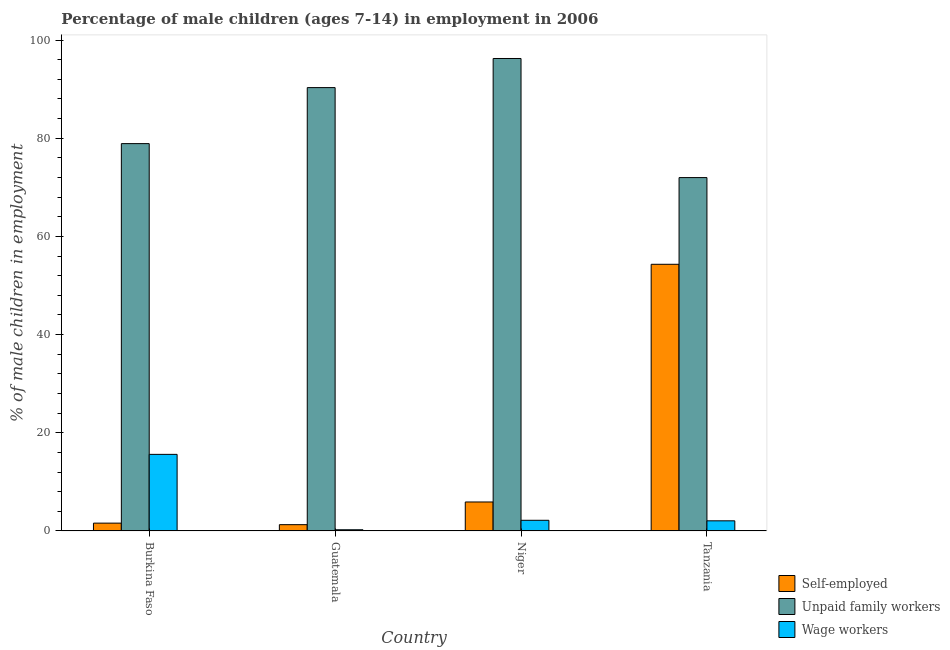How many bars are there on the 3rd tick from the left?
Give a very brief answer. 3. What is the label of the 1st group of bars from the left?
Provide a short and direct response. Burkina Faso. In how many cases, is the number of bars for a given country not equal to the number of legend labels?
Offer a very short reply. 0. What is the percentage of children employed as unpaid family workers in Guatemala?
Your answer should be compact. 90.31. Across all countries, what is the maximum percentage of children employed as unpaid family workers?
Provide a short and direct response. 96.24. Across all countries, what is the minimum percentage of children employed as unpaid family workers?
Your response must be concise. 71.98. In which country was the percentage of children employed as wage workers maximum?
Ensure brevity in your answer.  Burkina Faso. In which country was the percentage of children employed as wage workers minimum?
Provide a short and direct response. Guatemala. What is the total percentage of self employed children in the graph?
Your response must be concise. 63.09. What is the difference between the percentage of children employed as wage workers in Guatemala and that in Niger?
Your response must be concise. -1.93. What is the difference between the percentage of children employed as unpaid family workers in Guatemala and the percentage of self employed children in Tanzania?
Offer a very short reply. 35.99. What is the average percentage of self employed children per country?
Provide a short and direct response. 15.77. What is the difference between the percentage of self employed children and percentage of children employed as unpaid family workers in Burkina Faso?
Provide a succinct answer. -77.31. What is the ratio of the percentage of self employed children in Guatemala to that in Tanzania?
Your response must be concise. 0.02. What is the difference between the highest and the second highest percentage of children employed as wage workers?
Offer a very short reply. 13.43. What is the difference between the highest and the lowest percentage of self employed children?
Ensure brevity in your answer.  53.04. In how many countries, is the percentage of children employed as wage workers greater than the average percentage of children employed as wage workers taken over all countries?
Your response must be concise. 1. Is the sum of the percentage of children employed as wage workers in Guatemala and Tanzania greater than the maximum percentage of children employed as unpaid family workers across all countries?
Offer a terse response. No. What does the 3rd bar from the left in Burkina Faso represents?
Your answer should be compact. Wage workers. What does the 1st bar from the right in Guatemala represents?
Offer a very short reply. Wage workers. How many bars are there?
Give a very brief answer. 12. Are all the bars in the graph horizontal?
Your answer should be compact. No. What is the difference between two consecutive major ticks on the Y-axis?
Make the answer very short. 20. Does the graph contain grids?
Offer a terse response. No. What is the title of the graph?
Offer a very short reply. Percentage of male children (ages 7-14) in employment in 2006. Does "Primary" appear as one of the legend labels in the graph?
Keep it short and to the point. No. What is the label or title of the Y-axis?
Give a very brief answer. % of male children in employment. What is the % of male children in employment in Self-employed in Burkina Faso?
Your response must be concise. 1.59. What is the % of male children in employment in Unpaid family workers in Burkina Faso?
Your answer should be very brief. 78.9. What is the % of male children in employment in Wage workers in Burkina Faso?
Give a very brief answer. 15.6. What is the % of male children in employment of Self-employed in Guatemala?
Provide a succinct answer. 1.28. What is the % of male children in employment in Unpaid family workers in Guatemala?
Offer a very short reply. 90.31. What is the % of male children in employment of Wage workers in Guatemala?
Provide a succinct answer. 0.24. What is the % of male children in employment in Unpaid family workers in Niger?
Provide a succinct answer. 96.24. What is the % of male children in employment of Wage workers in Niger?
Provide a short and direct response. 2.17. What is the % of male children in employment in Self-employed in Tanzania?
Make the answer very short. 54.32. What is the % of male children in employment of Unpaid family workers in Tanzania?
Offer a very short reply. 71.98. What is the % of male children in employment in Wage workers in Tanzania?
Provide a short and direct response. 2.06. Across all countries, what is the maximum % of male children in employment of Self-employed?
Give a very brief answer. 54.32. Across all countries, what is the maximum % of male children in employment in Unpaid family workers?
Offer a terse response. 96.24. Across all countries, what is the minimum % of male children in employment of Self-employed?
Ensure brevity in your answer.  1.28. Across all countries, what is the minimum % of male children in employment in Unpaid family workers?
Keep it short and to the point. 71.98. Across all countries, what is the minimum % of male children in employment of Wage workers?
Your answer should be very brief. 0.24. What is the total % of male children in employment in Self-employed in the graph?
Your answer should be compact. 63.09. What is the total % of male children in employment of Unpaid family workers in the graph?
Provide a succinct answer. 337.43. What is the total % of male children in employment in Wage workers in the graph?
Ensure brevity in your answer.  20.07. What is the difference between the % of male children in employment in Self-employed in Burkina Faso and that in Guatemala?
Provide a succinct answer. 0.31. What is the difference between the % of male children in employment in Unpaid family workers in Burkina Faso and that in Guatemala?
Give a very brief answer. -11.41. What is the difference between the % of male children in employment of Wage workers in Burkina Faso and that in Guatemala?
Your answer should be compact. 15.36. What is the difference between the % of male children in employment in Self-employed in Burkina Faso and that in Niger?
Your answer should be compact. -4.31. What is the difference between the % of male children in employment in Unpaid family workers in Burkina Faso and that in Niger?
Provide a short and direct response. -17.34. What is the difference between the % of male children in employment in Wage workers in Burkina Faso and that in Niger?
Your answer should be very brief. 13.43. What is the difference between the % of male children in employment of Self-employed in Burkina Faso and that in Tanzania?
Offer a very short reply. -52.73. What is the difference between the % of male children in employment in Unpaid family workers in Burkina Faso and that in Tanzania?
Your answer should be very brief. 6.92. What is the difference between the % of male children in employment in Wage workers in Burkina Faso and that in Tanzania?
Your answer should be compact. 13.54. What is the difference between the % of male children in employment in Self-employed in Guatemala and that in Niger?
Offer a terse response. -4.62. What is the difference between the % of male children in employment of Unpaid family workers in Guatemala and that in Niger?
Keep it short and to the point. -5.93. What is the difference between the % of male children in employment in Wage workers in Guatemala and that in Niger?
Provide a succinct answer. -1.93. What is the difference between the % of male children in employment in Self-employed in Guatemala and that in Tanzania?
Offer a very short reply. -53.04. What is the difference between the % of male children in employment in Unpaid family workers in Guatemala and that in Tanzania?
Provide a succinct answer. 18.33. What is the difference between the % of male children in employment of Wage workers in Guatemala and that in Tanzania?
Keep it short and to the point. -1.82. What is the difference between the % of male children in employment in Self-employed in Niger and that in Tanzania?
Ensure brevity in your answer.  -48.42. What is the difference between the % of male children in employment in Unpaid family workers in Niger and that in Tanzania?
Ensure brevity in your answer.  24.26. What is the difference between the % of male children in employment of Wage workers in Niger and that in Tanzania?
Provide a short and direct response. 0.11. What is the difference between the % of male children in employment of Self-employed in Burkina Faso and the % of male children in employment of Unpaid family workers in Guatemala?
Offer a terse response. -88.72. What is the difference between the % of male children in employment in Self-employed in Burkina Faso and the % of male children in employment in Wage workers in Guatemala?
Offer a terse response. 1.35. What is the difference between the % of male children in employment of Unpaid family workers in Burkina Faso and the % of male children in employment of Wage workers in Guatemala?
Your response must be concise. 78.66. What is the difference between the % of male children in employment of Self-employed in Burkina Faso and the % of male children in employment of Unpaid family workers in Niger?
Offer a terse response. -94.65. What is the difference between the % of male children in employment in Self-employed in Burkina Faso and the % of male children in employment in Wage workers in Niger?
Offer a very short reply. -0.58. What is the difference between the % of male children in employment in Unpaid family workers in Burkina Faso and the % of male children in employment in Wage workers in Niger?
Provide a short and direct response. 76.73. What is the difference between the % of male children in employment of Self-employed in Burkina Faso and the % of male children in employment of Unpaid family workers in Tanzania?
Offer a terse response. -70.39. What is the difference between the % of male children in employment in Self-employed in Burkina Faso and the % of male children in employment in Wage workers in Tanzania?
Ensure brevity in your answer.  -0.47. What is the difference between the % of male children in employment of Unpaid family workers in Burkina Faso and the % of male children in employment of Wage workers in Tanzania?
Make the answer very short. 76.84. What is the difference between the % of male children in employment of Self-employed in Guatemala and the % of male children in employment of Unpaid family workers in Niger?
Give a very brief answer. -94.96. What is the difference between the % of male children in employment in Self-employed in Guatemala and the % of male children in employment in Wage workers in Niger?
Make the answer very short. -0.89. What is the difference between the % of male children in employment in Unpaid family workers in Guatemala and the % of male children in employment in Wage workers in Niger?
Give a very brief answer. 88.14. What is the difference between the % of male children in employment of Self-employed in Guatemala and the % of male children in employment of Unpaid family workers in Tanzania?
Provide a succinct answer. -70.7. What is the difference between the % of male children in employment of Self-employed in Guatemala and the % of male children in employment of Wage workers in Tanzania?
Give a very brief answer. -0.78. What is the difference between the % of male children in employment in Unpaid family workers in Guatemala and the % of male children in employment in Wage workers in Tanzania?
Your answer should be very brief. 88.25. What is the difference between the % of male children in employment of Self-employed in Niger and the % of male children in employment of Unpaid family workers in Tanzania?
Your answer should be compact. -66.08. What is the difference between the % of male children in employment of Self-employed in Niger and the % of male children in employment of Wage workers in Tanzania?
Offer a very short reply. 3.84. What is the difference between the % of male children in employment in Unpaid family workers in Niger and the % of male children in employment in Wage workers in Tanzania?
Make the answer very short. 94.18. What is the average % of male children in employment of Self-employed per country?
Offer a terse response. 15.77. What is the average % of male children in employment of Unpaid family workers per country?
Provide a succinct answer. 84.36. What is the average % of male children in employment of Wage workers per country?
Offer a very short reply. 5.02. What is the difference between the % of male children in employment of Self-employed and % of male children in employment of Unpaid family workers in Burkina Faso?
Provide a short and direct response. -77.31. What is the difference between the % of male children in employment in Self-employed and % of male children in employment in Wage workers in Burkina Faso?
Your answer should be compact. -14.01. What is the difference between the % of male children in employment in Unpaid family workers and % of male children in employment in Wage workers in Burkina Faso?
Offer a very short reply. 63.3. What is the difference between the % of male children in employment in Self-employed and % of male children in employment in Unpaid family workers in Guatemala?
Keep it short and to the point. -89.03. What is the difference between the % of male children in employment of Unpaid family workers and % of male children in employment of Wage workers in Guatemala?
Make the answer very short. 90.07. What is the difference between the % of male children in employment in Self-employed and % of male children in employment in Unpaid family workers in Niger?
Your answer should be very brief. -90.34. What is the difference between the % of male children in employment of Self-employed and % of male children in employment of Wage workers in Niger?
Provide a short and direct response. 3.73. What is the difference between the % of male children in employment of Unpaid family workers and % of male children in employment of Wage workers in Niger?
Your response must be concise. 94.07. What is the difference between the % of male children in employment of Self-employed and % of male children in employment of Unpaid family workers in Tanzania?
Your answer should be compact. -17.66. What is the difference between the % of male children in employment of Self-employed and % of male children in employment of Wage workers in Tanzania?
Your answer should be compact. 52.26. What is the difference between the % of male children in employment in Unpaid family workers and % of male children in employment in Wage workers in Tanzania?
Your answer should be compact. 69.92. What is the ratio of the % of male children in employment of Self-employed in Burkina Faso to that in Guatemala?
Give a very brief answer. 1.24. What is the ratio of the % of male children in employment in Unpaid family workers in Burkina Faso to that in Guatemala?
Provide a succinct answer. 0.87. What is the ratio of the % of male children in employment of Wage workers in Burkina Faso to that in Guatemala?
Offer a terse response. 65. What is the ratio of the % of male children in employment in Self-employed in Burkina Faso to that in Niger?
Offer a very short reply. 0.27. What is the ratio of the % of male children in employment of Unpaid family workers in Burkina Faso to that in Niger?
Ensure brevity in your answer.  0.82. What is the ratio of the % of male children in employment of Wage workers in Burkina Faso to that in Niger?
Provide a succinct answer. 7.19. What is the ratio of the % of male children in employment of Self-employed in Burkina Faso to that in Tanzania?
Keep it short and to the point. 0.03. What is the ratio of the % of male children in employment of Unpaid family workers in Burkina Faso to that in Tanzania?
Your answer should be compact. 1.1. What is the ratio of the % of male children in employment of Wage workers in Burkina Faso to that in Tanzania?
Your answer should be very brief. 7.57. What is the ratio of the % of male children in employment in Self-employed in Guatemala to that in Niger?
Provide a succinct answer. 0.22. What is the ratio of the % of male children in employment of Unpaid family workers in Guatemala to that in Niger?
Offer a terse response. 0.94. What is the ratio of the % of male children in employment in Wage workers in Guatemala to that in Niger?
Provide a succinct answer. 0.11. What is the ratio of the % of male children in employment of Self-employed in Guatemala to that in Tanzania?
Ensure brevity in your answer.  0.02. What is the ratio of the % of male children in employment of Unpaid family workers in Guatemala to that in Tanzania?
Your answer should be very brief. 1.25. What is the ratio of the % of male children in employment in Wage workers in Guatemala to that in Tanzania?
Your answer should be very brief. 0.12. What is the ratio of the % of male children in employment of Self-employed in Niger to that in Tanzania?
Give a very brief answer. 0.11. What is the ratio of the % of male children in employment in Unpaid family workers in Niger to that in Tanzania?
Your answer should be very brief. 1.34. What is the ratio of the % of male children in employment in Wage workers in Niger to that in Tanzania?
Ensure brevity in your answer.  1.05. What is the difference between the highest and the second highest % of male children in employment of Self-employed?
Your answer should be compact. 48.42. What is the difference between the highest and the second highest % of male children in employment in Unpaid family workers?
Make the answer very short. 5.93. What is the difference between the highest and the second highest % of male children in employment in Wage workers?
Make the answer very short. 13.43. What is the difference between the highest and the lowest % of male children in employment of Self-employed?
Ensure brevity in your answer.  53.04. What is the difference between the highest and the lowest % of male children in employment of Unpaid family workers?
Provide a short and direct response. 24.26. What is the difference between the highest and the lowest % of male children in employment in Wage workers?
Give a very brief answer. 15.36. 